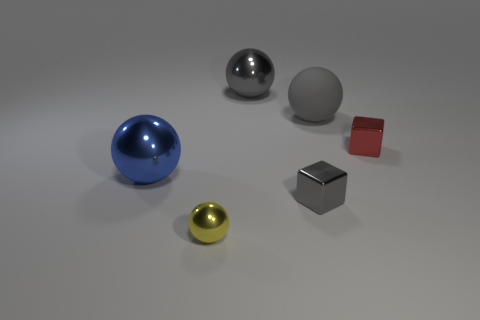Subtract all yellow blocks. How many gray spheres are left? 2 Subtract all yellow balls. How many balls are left? 3 Subtract all small yellow spheres. How many spheres are left? 3 Add 4 tiny purple shiny cylinders. How many objects exist? 10 Subtract all cyan spheres. Subtract all cyan blocks. How many spheres are left? 4 Subtract all balls. How many objects are left? 2 Add 5 big gray things. How many big gray things are left? 7 Add 6 yellow shiny cubes. How many yellow shiny cubes exist? 6 Subtract 1 red blocks. How many objects are left? 5 Subtract all small yellow metallic spheres. Subtract all red metallic blocks. How many objects are left? 4 